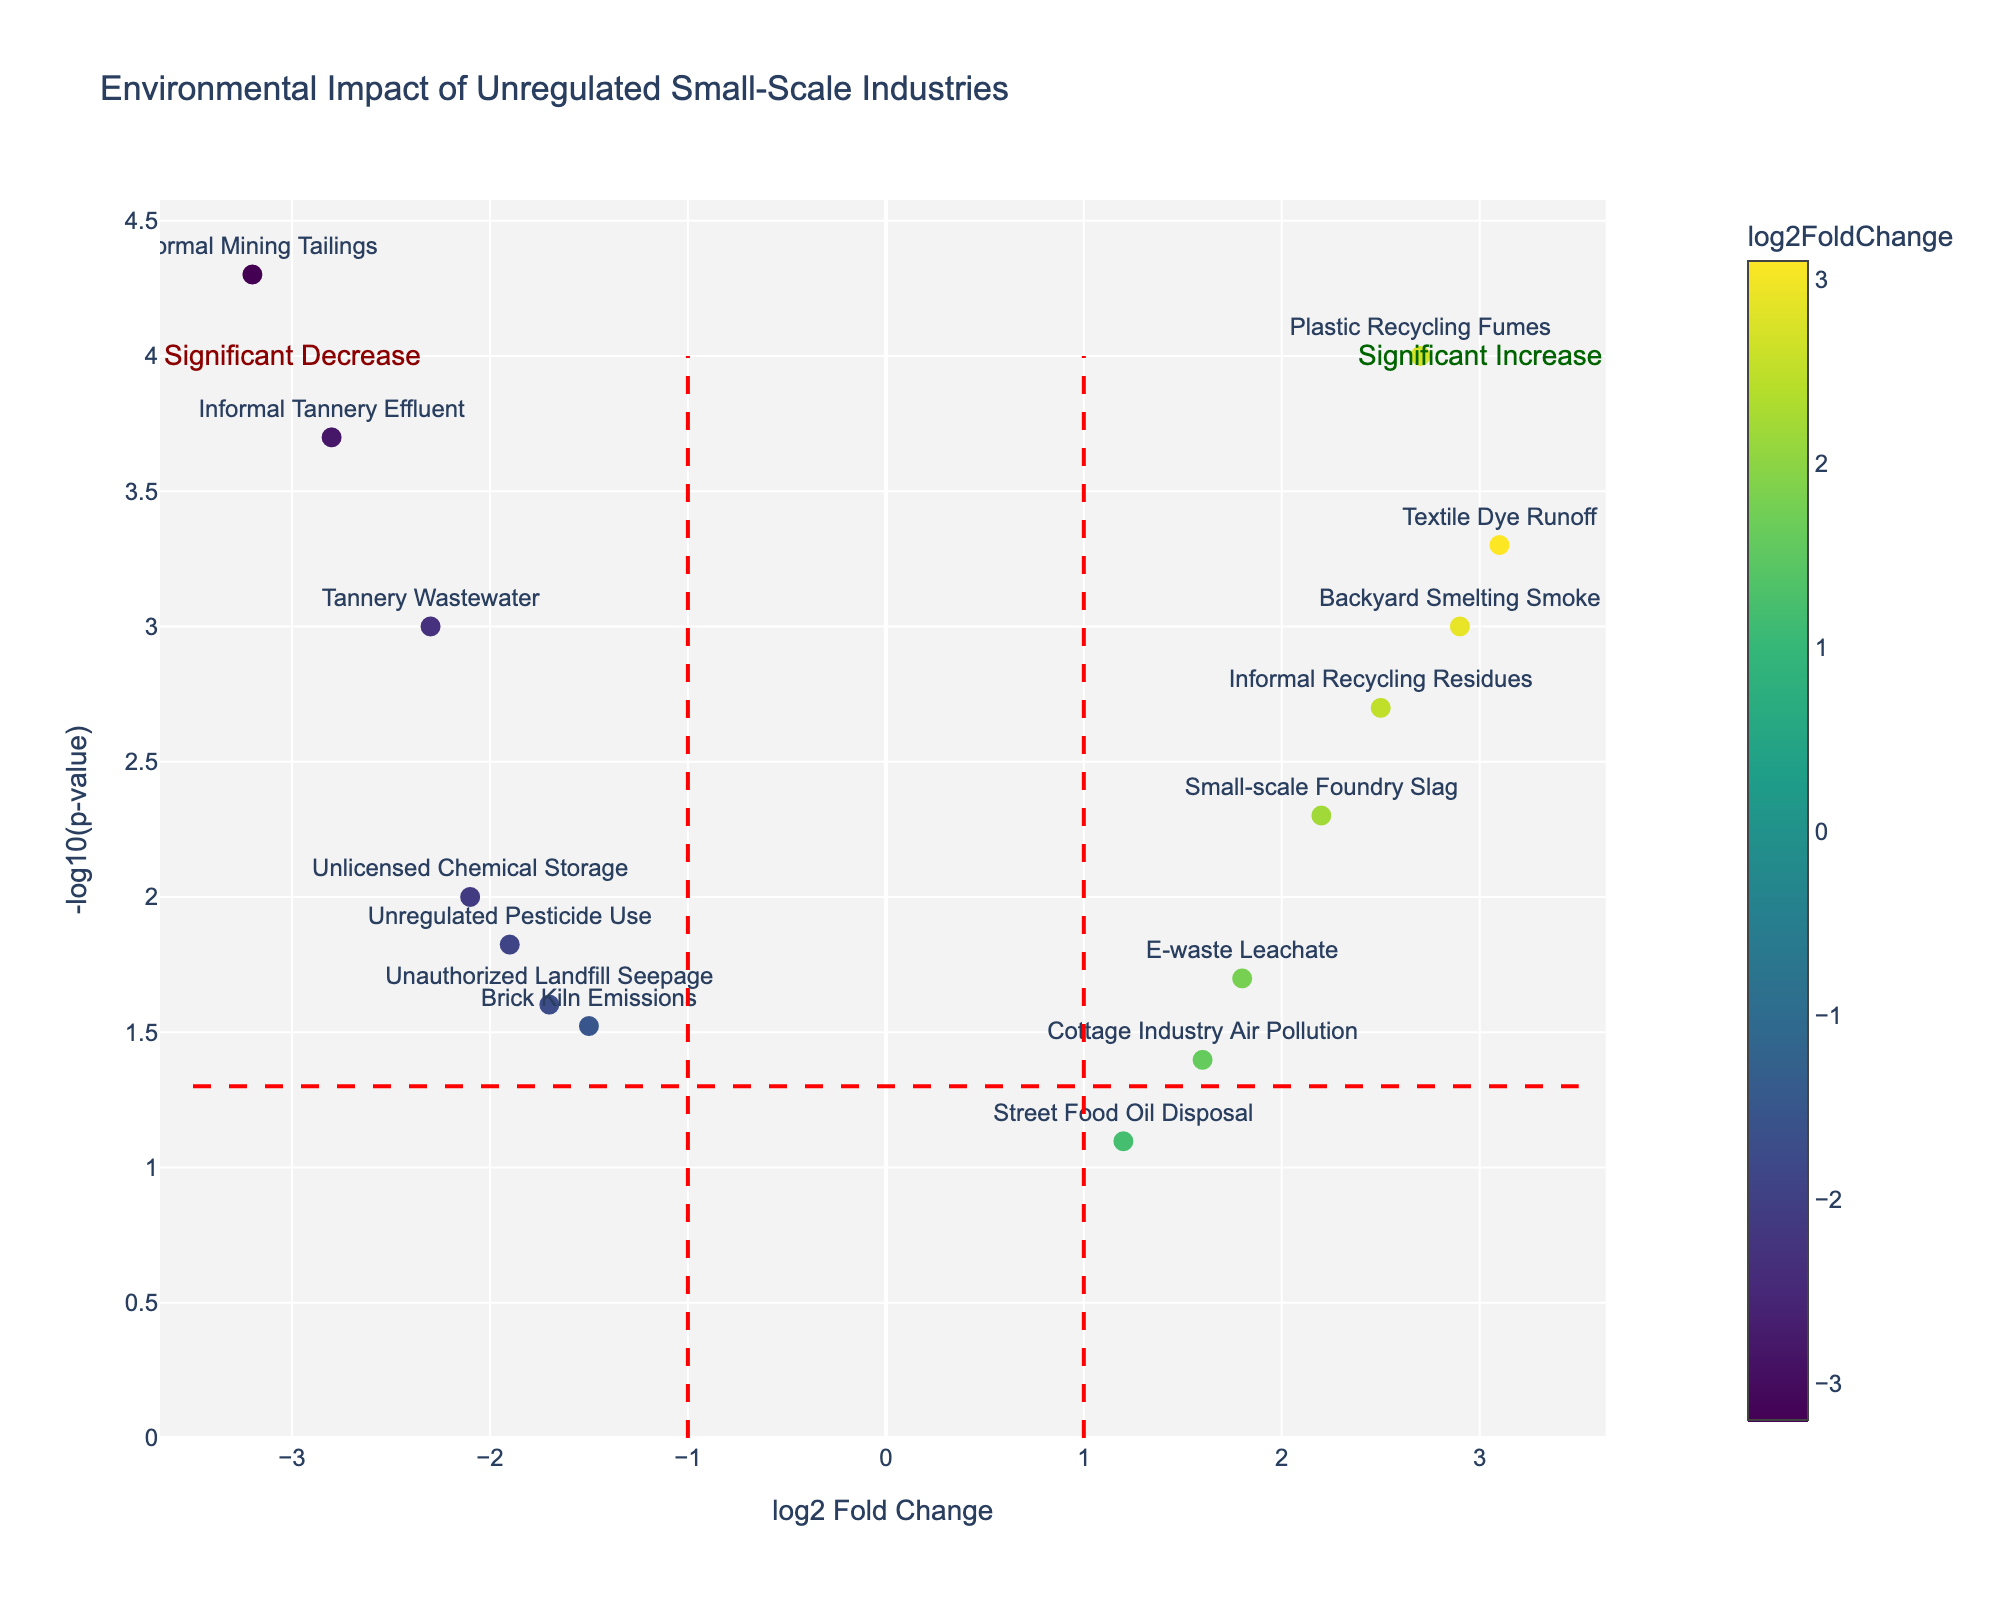Which data point represents the most significant increase in environmental impact? The data point with the highest log2FoldChange and the lowest p-value (hence highest -log10(p-value)) is usually the most significant. For this plot, "Informal Mining Tailings" has the highest significance.
Answer: Informal Mining Tailings What are the labels of the data points with log2FoldChange greater than 2? Looking at data points with x-axis values greater than 2, and checking their labels, we find "Textile Dye Runoff," "Plastic Recycling Fumes," "Backyard Smelting Smoke," "Small-scale Foundry Slag," and "Informal Recycling Residues."
Answer: Textile Dye Runoff, Plastic Recycling Fumes, Backyard Smelting Smoke, Small-scale Foundry Slag, Informal Recycling Residues Which data point has the lowest p-value? The lowest p-value corresponds to the highest -log10(p-value). Checking the y-values, "Informal Mining Tailings" has the highest, suggesting it has the lowest p-value.
Answer: Informal Mining Tailings How many data points have a significant increase in environmental impact? Data points are considered significantly increased if they have a log2FoldChange > 1 and p-value < 0.05. Counting such data points, we have five: "Textile Dye Runoff," "Plastic Recycling Fumes," "Backyard Smelting Smoke," "Small-scale Foundry Slag," and "Informal Recycling Residues."
Answer: 5 Which data points fall below the threshold of significance (p-value > 0.05)? Points above -log10(0.05) ≈ 1.3 on the y-axis. "Street Food Oil Disposal" and "Cottage Industry Air Pollution" have p-values > 0.05.
Answer: Street Food Oil Disposal, Cottage Industry Air Pollution How many data points have a log2FoldChange less than -1? Counting the x-axis values that are less than -1 and checking their labels, we find "Tannery Wastewater," "Informal Mining Tailings," "Unregulated Pesticide Use," "Unauthorized Landfill Seepage," and "Brick Kiln Emissions."
Answer: 5 Which industry has a log2FoldChange closest to zero? Looking for the data point with a log2FoldChange nearest to zero, "Street Food Oil Disposal" has the log2FoldChange of 1.2, the closest to zero among all.
Answer: Street Food Oil Disposal What is the log2FoldChange and p-value of "Informal Tannery Effluent"? Refer to the corresponding x and y positions for "Informal Tannery Effluent." The log2FoldChange is -2.8, and its p-value is 0.0002.
Answer: log2FoldChange: -2.8, p-value: 0.0002 How many data points have either log2FoldChange > 2 or p-value < 0.01? Identify data points satisfying either condition. 7 points meet these conditions: "Textile Dye Runoff," "Plastic Recycling Fumes," "Backyard Smelting Smoke," "Informal Tannery Effluent," "Small-scale Foundry Slag," "Informal Recycling Residues," and "Informal Mining Tailings."
Answer: 7 